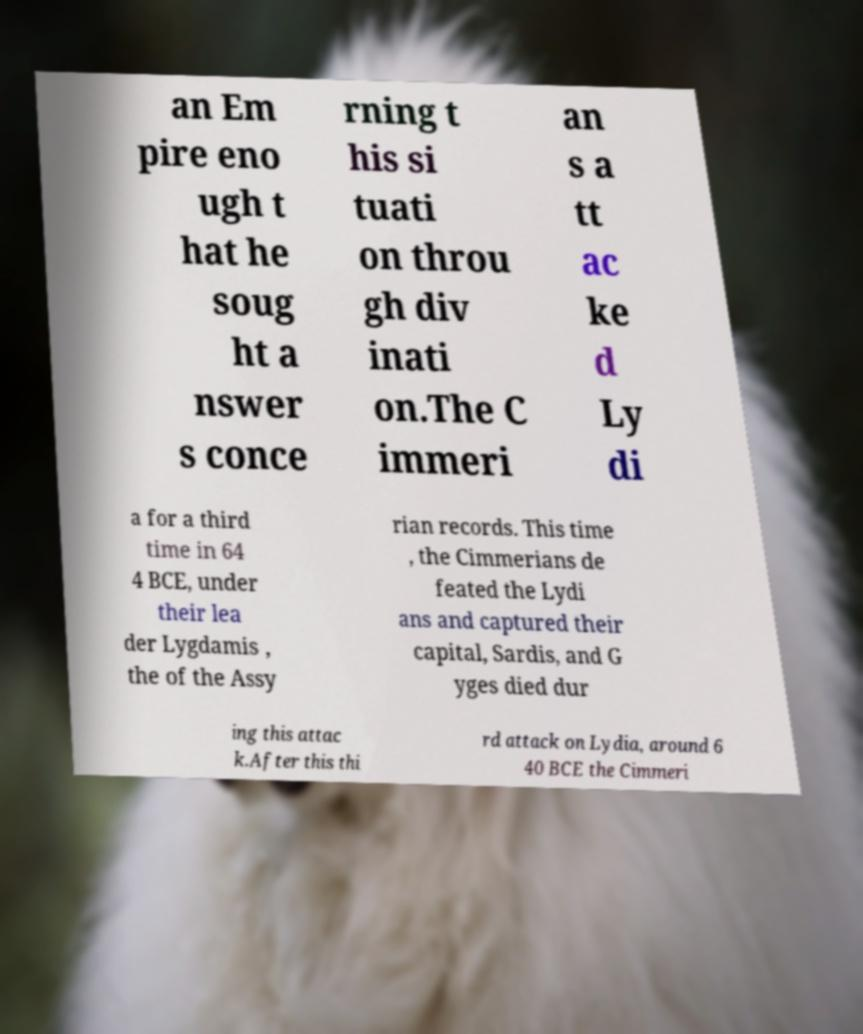For documentation purposes, I need the text within this image transcribed. Could you provide that? an Em pire eno ugh t hat he soug ht a nswer s conce rning t his si tuati on throu gh div inati on.The C immeri an s a tt ac ke d Ly di a for a third time in 64 4 BCE, under their lea der Lygdamis , the of the Assy rian records. This time , the Cimmerians de feated the Lydi ans and captured their capital, Sardis, and G yges died dur ing this attac k.After this thi rd attack on Lydia, around 6 40 BCE the Cimmeri 